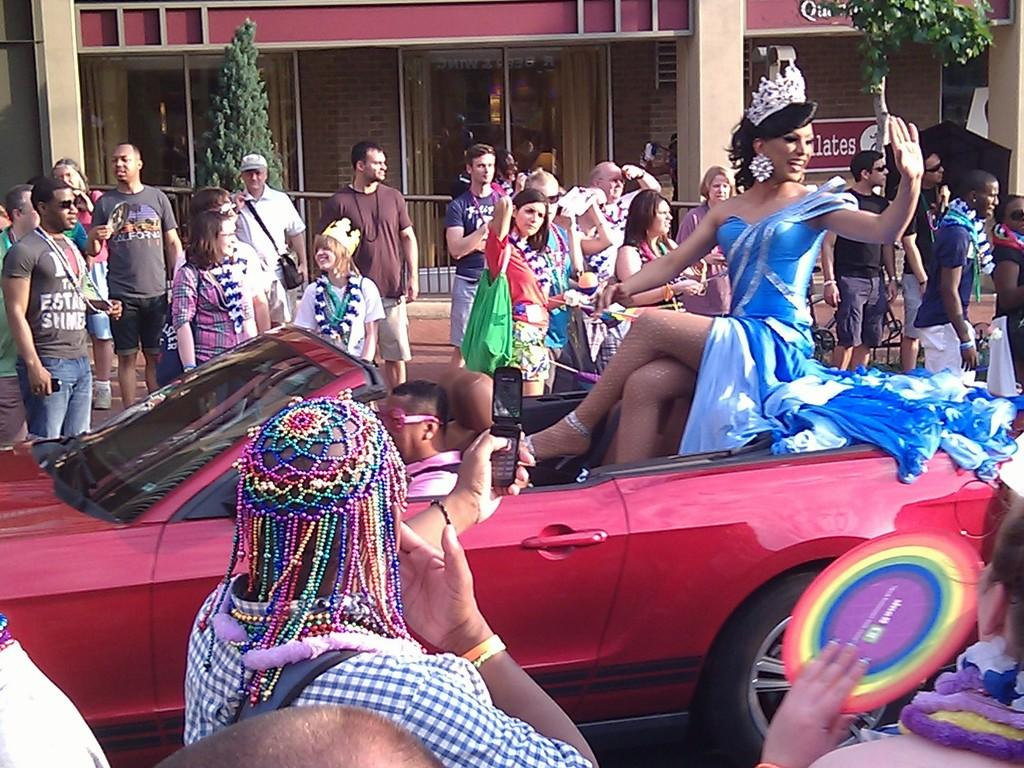What is the main subject of the picture? The main subject of the picture is a car. Who is operating the car? The car has a driver. Are there any passengers in the car? Yes, there is a woman sitting on the car. What can be seen in the background of the picture? There is a crowd in the background of the picture. What type of joke is the driver telling the woman sitting on the car? There is no indication in the image that the driver is telling a joke, so it cannot be determined from the picture. 